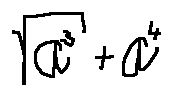Convert formula to latex. <formula><loc_0><loc_0><loc_500><loc_500>\sqrt { a ^ { 3 } } + a ^ { 4 }</formula> 